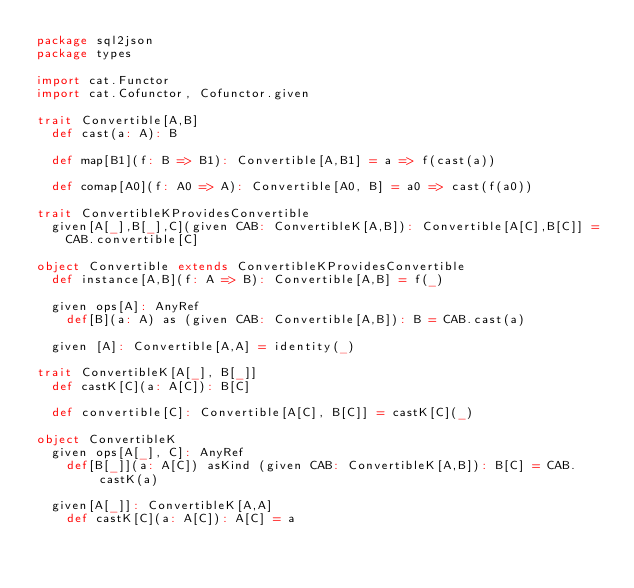<code> <loc_0><loc_0><loc_500><loc_500><_Scala_>package sql2json
package types

import cat.Functor
import cat.Cofunctor, Cofunctor.given

trait Convertible[A,B]
  def cast(a: A): B

  def map[B1](f: B => B1): Convertible[A,B1] = a => f(cast(a))

  def comap[A0](f: A0 => A): Convertible[A0, B] = a0 => cast(f(a0))

trait ConvertibleKProvidesConvertible
  given[A[_],B[_],C](given CAB: ConvertibleK[A,B]): Convertible[A[C],B[C]] = 
    CAB.convertible[C]

object Convertible extends ConvertibleKProvidesConvertible
  def instance[A,B](f: A => B): Convertible[A,B] = f(_)

  given ops[A]: AnyRef
    def[B](a: A) as (given CAB: Convertible[A,B]): B = CAB.cast(a)

  given [A]: Convertible[A,A] = identity(_)

trait ConvertibleK[A[_], B[_]]
  def castK[C](a: A[C]): B[C]

  def convertible[C]: Convertible[A[C], B[C]] = castK[C](_)

object ConvertibleK
  given ops[A[_], C]: AnyRef
    def[B[_]](a: A[C]) asKind (given CAB: ConvertibleK[A,B]): B[C] = CAB.castK(a)

  given[A[_]]: ConvertibleK[A,A]
    def castK[C](a: A[C]): A[C] = a</code> 